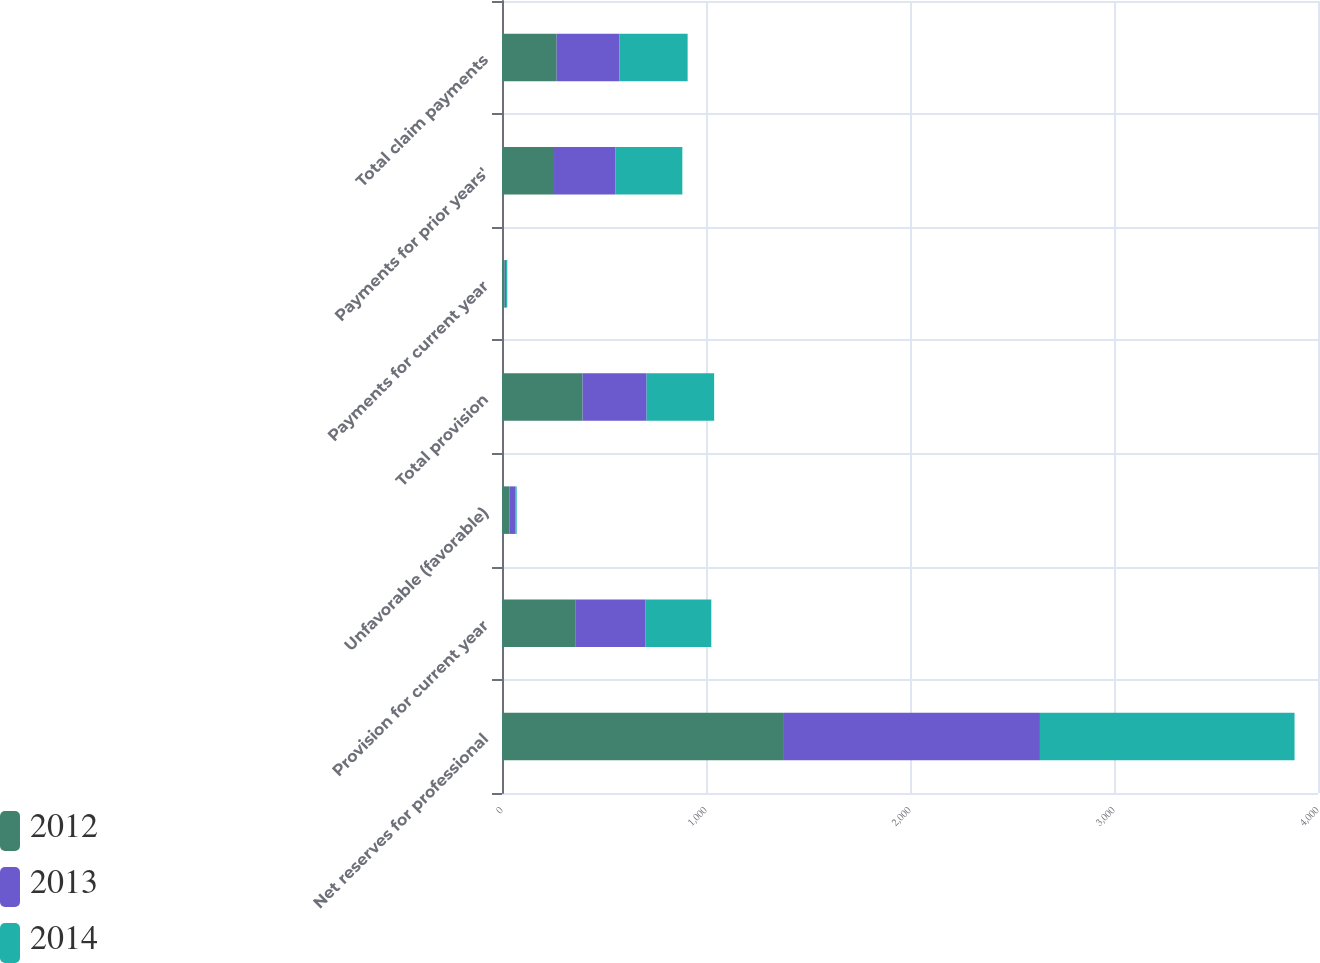Convert chart. <chart><loc_0><loc_0><loc_500><loc_500><stacked_bar_chart><ecel><fcel>Net reserves for professional<fcel>Provision for current year<fcel>Unfavorable (favorable)<fcel>Total provision<fcel>Payments for current year<fcel>Payments for prior years'<fcel>Total claim payments<nl><fcel>2012<fcel>1382<fcel>359<fcel>36<fcel>395<fcel>13<fcel>255<fcel>268<nl><fcel>2013<fcel>1255<fcel>343<fcel>29<fcel>314<fcel>7<fcel>300<fcel>307<nl><fcel>2014<fcel>1248<fcel>324<fcel>7<fcel>331<fcel>6<fcel>329<fcel>335<nl></chart> 